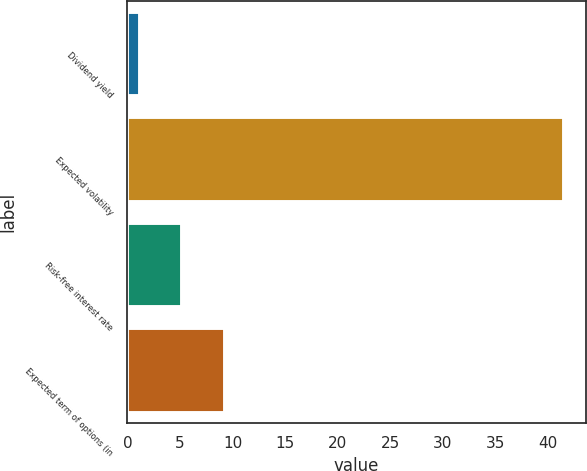<chart> <loc_0><loc_0><loc_500><loc_500><bar_chart><fcel>Dividend yield<fcel>Expected volatility<fcel>Risk-free interest rate<fcel>Expected term of options (in<nl><fcel>1.18<fcel>41.54<fcel>5.22<fcel>9.26<nl></chart> 